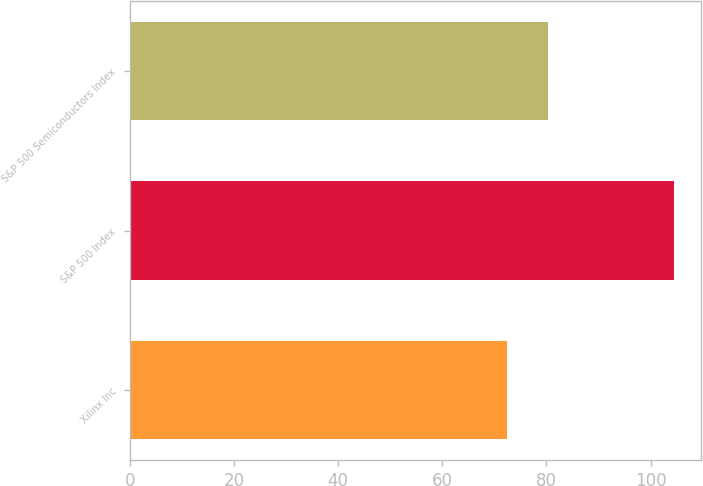<chart> <loc_0><loc_0><loc_500><loc_500><bar_chart><fcel>Xilinx Inc<fcel>S&P 500 Index<fcel>S&P 500 Semiconductors Index<nl><fcel>72.47<fcel>104.55<fcel>80.37<nl></chart> 